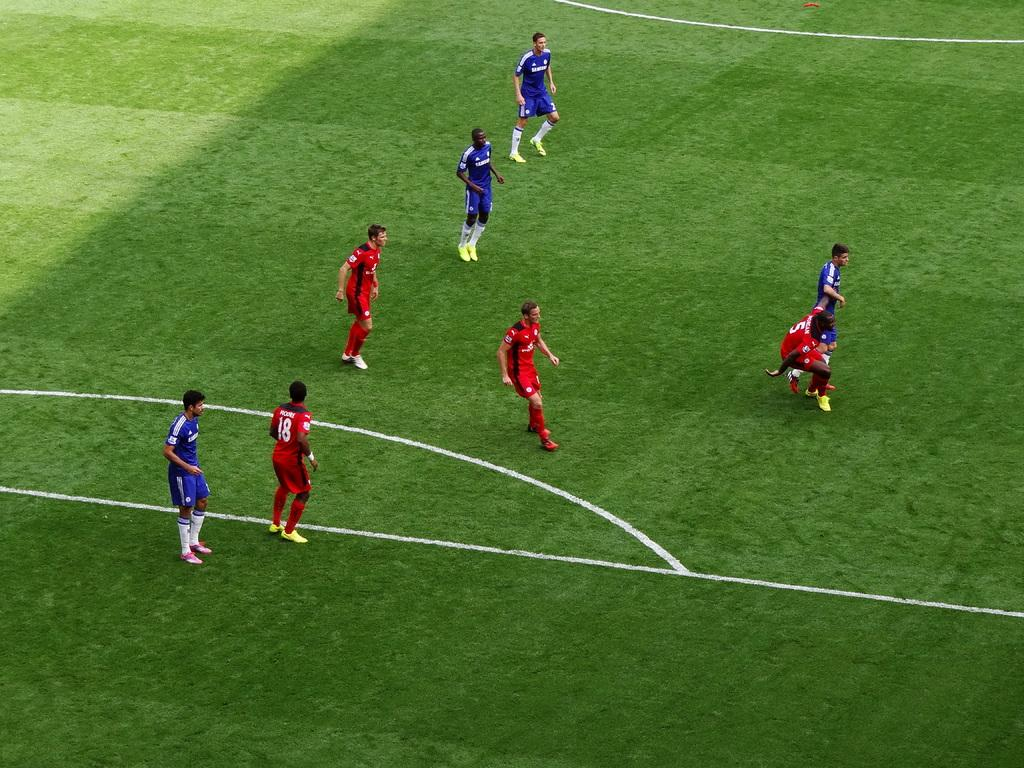<image>
Share a concise interpretation of the image provided. Two soccer teams in red and blue run up the field, among them number 18, 